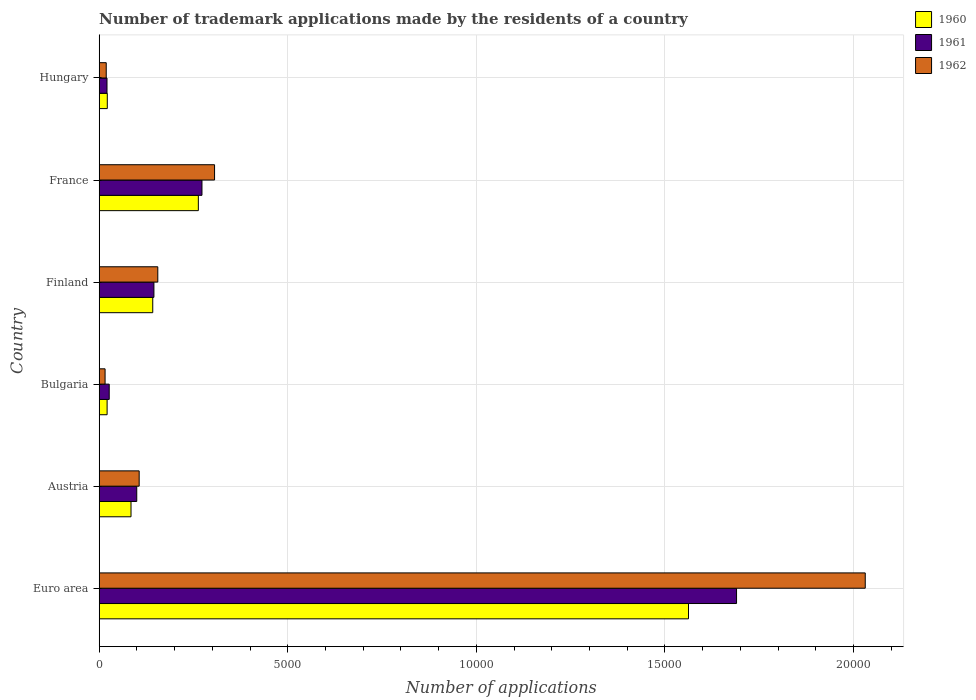How many groups of bars are there?
Your answer should be compact. 6. Are the number of bars on each tick of the Y-axis equal?
Your answer should be very brief. Yes. How many bars are there on the 4th tick from the top?
Your answer should be very brief. 3. How many bars are there on the 3rd tick from the bottom?
Give a very brief answer. 3. In how many cases, is the number of bars for a given country not equal to the number of legend labels?
Offer a very short reply. 0. What is the number of trademark applications made by the residents in 1962 in Austria?
Provide a short and direct response. 1061. Across all countries, what is the maximum number of trademark applications made by the residents in 1960?
Offer a very short reply. 1.56e+04. Across all countries, what is the minimum number of trademark applications made by the residents in 1962?
Provide a short and direct response. 157. In which country was the number of trademark applications made by the residents in 1960 maximum?
Make the answer very short. Euro area. In which country was the number of trademark applications made by the residents in 1962 minimum?
Provide a succinct answer. Bulgaria. What is the total number of trademark applications made by the residents in 1960 in the graph?
Your answer should be compact. 2.09e+04. What is the difference between the number of trademark applications made by the residents in 1960 in Euro area and that in France?
Offer a very short reply. 1.30e+04. What is the difference between the number of trademark applications made by the residents in 1961 in Euro area and the number of trademark applications made by the residents in 1960 in Hungary?
Provide a short and direct response. 1.67e+04. What is the average number of trademark applications made by the residents in 1961 per country?
Give a very brief answer. 3758.17. What is the difference between the number of trademark applications made by the residents in 1962 and number of trademark applications made by the residents in 1961 in France?
Keep it short and to the point. 334. What is the ratio of the number of trademark applications made by the residents in 1960 in Euro area to that in Hungary?
Provide a short and direct response. 72.34. Is the number of trademark applications made by the residents in 1960 in Austria less than that in Bulgaria?
Keep it short and to the point. No. What is the difference between the highest and the second highest number of trademark applications made by the residents in 1962?
Offer a very short reply. 1.73e+04. What is the difference between the highest and the lowest number of trademark applications made by the residents in 1960?
Offer a terse response. 1.54e+04. What does the 1st bar from the bottom in Euro area represents?
Ensure brevity in your answer.  1960. Are all the bars in the graph horizontal?
Provide a short and direct response. Yes. Are the values on the major ticks of X-axis written in scientific E-notation?
Ensure brevity in your answer.  No. How many legend labels are there?
Provide a short and direct response. 3. What is the title of the graph?
Your answer should be compact. Number of trademark applications made by the residents of a country. What is the label or title of the X-axis?
Provide a succinct answer. Number of applications. What is the Number of applications in 1960 in Euro area?
Ensure brevity in your answer.  1.56e+04. What is the Number of applications of 1961 in Euro area?
Provide a short and direct response. 1.69e+04. What is the Number of applications in 1962 in Euro area?
Your response must be concise. 2.03e+04. What is the Number of applications of 1960 in Austria?
Your answer should be compact. 845. What is the Number of applications of 1961 in Austria?
Ensure brevity in your answer.  997. What is the Number of applications of 1962 in Austria?
Offer a terse response. 1061. What is the Number of applications in 1960 in Bulgaria?
Make the answer very short. 211. What is the Number of applications in 1961 in Bulgaria?
Make the answer very short. 267. What is the Number of applications in 1962 in Bulgaria?
Your answer should be very brief. 157. What is the Number of applications of 1960 in Finland?
Your answer should be very brief. 1421. What is the Number of applications in 1961 in Finland?
Provide a succinct answer. 1452. What is the Number of applications in 1962 in Finland?
Make the answer very short. 1555. What is the Number of applications of 1960 in France?
Your answer should be very brief. 2630. What is the Number of applications of 1961 in France?
Make the answer very short. 2726. What is the Number of applications in 1962 in France?
Your answer should be very brief. 3060. What is the Number of applications of 1960 in Hungary?
Your answer should be compact. 216. What is the Number of applications in 1961 in Hungary?
Provide a succinct answer. 208. What is the Number of applications of 1962 in Hungary?
Make the answer very short. 188. Across all countries, what is the maximum Number of applications of 1960?
Provide a succinct answer. 1.56e+04. Across all countries, what is the maximum Number of applications of 1961?
Provide a succinct answer. 1.69e+04. Across all countries, what is the maximum Number of applications of 1962?
Ensure brevity in your answer.  2.03e+04. Across all countries, what is the minimum Number of applications of 1960?
Keep it short and to the point. 211. Across all countries, what is the minimum Number of applications in 1961?
Ensure brevity in your answer.  208. Across all countries, what is the minimum Number of applications in 1962?
Keep it short and to the point. 157. What is the total Number of applications of 1960 in the graph?
Keep it short and to the point. 2.09e+04. What is the total Number of applications in 1961 in the graph?
Your answer should be compact. 2.25e+04. What is the total Number of applications in 1962 in the graph?
Your answer should be very brief. 2.63e+04. What is the difference between the Number of applications in 1960 in Euro area and that in Austria?
Ensure brevity in your answer.  1.48e+04. What is the difference between the Number of applications in 1961 in Euro area and that in Austria?
Make the answer very short. 1.59e+04. What is the difference between the Number of applications of 1962 in Euro area and that in Austria?
Provide a succinct answer. 1.92e+04. What is the difference between the Number of applications of 1960 in Euro area and that in Bulgaria?
Make the answer very short. 1.54e+04. What is the difference between the Number of applications of 1961 in Euro area and that in Bulgaria?
Offer a terse response. 1.66e+04. What is the difference between the Number of applications of 1962 in Euro area and that in Bulgaria?
Offer a terse response. 2.02e+04. What is the difference between the Number of applications of 1960 in Euro area and that in Finland?
Your answer should be compact. 1.42e+04. What is the difference between the Number of applications in 1961 in Euro area and that in Finland?
Your answer should be very brief. 1.54e+04. What is the difference between the Number of applications in 1962 in Euro area and that in Finland?
Offer a very short reply. 1.88e+04. What is the difference between the Number of applications of 1960 in Euro area and that in France?
Your answer should be very brief. 1.30e+04. What is the difference between the Number of applications in 1961 in Euro area and that in France?
Offer a very short reply. 1.42e+04. What is the difference between the Number of applications of 1962 in Euro area and that in France?
Ensure brevity in your answer.  1.73e+04. What is the difference between the Number of applications in 1960 in Euro area and that in Hungary?
Offer a very short reply. 1.54e+04. What is the difference between the Number of applications of 1961 in Euro area and that in Hungary?
Offer a terse response. 1.67e+04. What is the difference between the Number of applications of 1962 in Euro area and that in Hungary?
Provide a short and direct response. 2.01e+04. What is the difference between the Number of applications of 1960 in Austria and that in Bulgaria?
Offer a terse response. 634. What is the difference between the Number of applications in 1961 in Austria and that in Bulgaria?
Your answer should be very brief. 730. What is the difference between the Number of applications of 1962 in Austria and that in Bulgaria?
Provide a short and direct response. 904. What is the difference between the Number of applications in 1960 in Austria and that in Finland?
Offer a terse response. -576. What is the difference between the Number of applications of 1961 in Austria and that in Finland?
Offer a very short reply. -455. What is the difference between the Number of applications of 1962 in Austria and that in Finland?
Provide a succinct answer. -494. What is the difference between the Number of applications of 1960 in Austria and that in France?
Provide a short and direct response. -1785. What is the difference between the Number of applications of 1961 in Austria and that in France?
Keep it short and to the point. -1729. What is the difference between the Number of applications of 1962 in Austria and that in France?
Provide a short and direct response. -1999. What is the difference between the Number of applications of 1960 in Austria and that in Hungary?
Give a very brief answer. 629. What is the difference between the Number of applications of 1961 in Austria and that in Hungary?
Ensure brevity in your answer.  789. What is the difference between the Number of applications of 1962 in Austria and that in Hungary?
Make the answer very short. 873. What is the difference between the Number of applications of 1960 in Bulgaria and that in Finland?
Give a very brief answer. -1210. What is the difference between the Number of applications in 1961 in Bulgaria and that in Finland?
Your answer should be very brief. -1185. What is the difference between the Number of applications of 1962 in Bulgaria and that in Finland?
Give a very brief answer. -1398. What is the difference between the Number of applications in 1960 in Bulgaria and that in France?
Your response must be concise. -2419. What is the difference between the Number of applications in 1961 in Bulgaria and that in France?
Keep it short and to the point. -2459. What is the difference between the Number of applications in 1962 in Bulgaria and that in France?
Offer a terse response. -2903. What is the difference between the Number of applications in 1961 in Bulgaria and that in Hungary?
Provide a succinct answer. 59. What is the difference between the Number of applications of 1962 in Bulgaria and that in Hungary?
Provide a short and direct response. -31. What is the difference between the Number of applications of 1960 in Finland and that in France?
Keep it short and to the point. -1209. What is the difference between the Number of applications of 1961 in Finland and that in France?
Offer a terse response. -1274. What is the difference between the Number of applications in 1962 in Finland and that in France?
Offer a terse response. -1505. What is the difference between the Number of applications of 1960 in Finland and that in Hungary?
Ensure brevity in your answer.  1205. What is the difference between the Number of applications in 1961 in Finland and that in Hungary?
Offer a very short reply. 1244. What is the difference between the Number of applications of 1962 in Finland and that in Hungary?
Provide a short and direct response. 1367. What is the difference between the Number of applications in 1960 in France and that in Hungary?
Give a very brief answer. 2414. What is the difference between the Number of applications of 1961 in France and that in Hungary?
Make the answer very short. 2518. What is the difference between the Number of applications in 1962 in France and that in Hungary?
Offer a terse response. 2872. What is the difference between the Number of applications of 1960 in Euro area and the Number of applications of 1961 in Austria?
Your answer should be very brief. 1.46e+04. What is the difference between the Number of applications in 1960 in Euro area and the Number of applications in 1962 in Austria?
Make the answer very short. 1.46e+04. What is the difference between the Number of applications of 1961 in Euro area and the Number of applications of 1962 in Austria?
Your answer should be very brief. 1.58e+04. What is the difference between the Number of applications in 1960 in Euro area and the Number of applications in 1961 in Bulgaria?
Make the answer very short. 1.54e+04. What is the difference between the Number of applications in 1960 in Euro area and the Number of applications in 1962 in Bulgaria?
Provide a short and direct response. 1.55e+04. What is the difference between the Number of applications of 1961 in Euro area and the Number of applications of 1962 in Bulgaria?
Your answer should be compact. 1.67e+04. What is the difference between the Number of applications of 1960 in Euro area and the Number of applications of 1961 in Finland?
Offer a terse response. 1.42e+04. What is the difference between the Number of applications of 1960 in Euro area and the Number of applications of 1962 in Finland?
Make the answer very short. 1.41e+04. What is the difference between the Number of applications in 1961 in Euro area and the Number of applications in 1962 in Finland?
Give a very brief answer. 1.53e+04. What is the difference between the Number of applications of 1960 in Euro area and the Number of applications of 1961 in France?
Ensure brevity in your answer.  1.29e+04. What is the difference between the Number of applications in 1960 in Euro area and the Number of applications in 1962 in France?
Give a very brief answer. 1.26e+04. What is the difference between the Number of applications in 1961 in Euro area and the Number of applications in 1962 in France?
Offer a very short reply. 1.38e+04. What is the difference between the Number of applications in 1960 in Euro area and the Number of applications in 1961 in Hungary?
Offer a terse response. 1.54e+04. What is the difference between the Number of applications in 1960 in Euro area and the Number of applications in 1962 in Hungary?
Make the answer very short. 1.54e+04. What is the difference between the Number of applications in 1961 in Euro area and the Number of applications in 1962 in Hungary?
Your response must be concise. 1.67e+04. What is the difference between the Number of applications in 1960 in Austria and the Number of applications in 1961 in Bulgaria?
Give a very brief answer. 578. What is the difference between the Number of applications in 1960 in Austria and the Number of applications in 1962 in Bulgaria?
Ensure brevity in your answer.  688. What is the difference between the Number of applications in 1961 in Austria and the Number of applications in 1962 in Bulgaria?
Offer a terse response. 840. What is the difference between the Number of applications in 1960 in Austria and the Number of applications in 1961 in Finland?
Provide a succinct answer. -607. What is the difference between the Number of applications in 1960 in Austria and the Number of applications in 1962 in Finland?
Keep it short and to the point. -710. What is the difference between the Number of applications in 1961 in Austria and the Number of applications in 1962 in Finland?
Your answer should be compact. -558. What is the difference between the Number of applications in 1960 in Austria and the Number of applications in 1961 in France?
Give a very brief answer. -1881. What is the difference between the Number of applications in 1960 in Austria and the Number of applications in 1962 in France?
Offer a terse response. -2215. What is the difference between the Number of applications in 1961 in Austria and the Number of applications in 1962 in France?
Offer a very short reply. -2063. What is the difference between the Number of applications in 1960 in Austria and the Number of applications in 1961 in Hungary?
Make the answer very short. 637. What is the difference between the Number of applications of 1960 in Austria and the Number of applications of 1962 in Hungary?
Provide a short and direct response. 657. What is the difference between the Number of applications in 1961 in Austria and the Number of applications in 1962 in Hungary?
Your answer should be very brief. 809. What is the difference between the Number of applications of 1960 in Bulgaria and the Number of applications of 1961 in Finland?
Provide a succinct answer. -1241. What is the difference between the Number of applications in 1960 in Bulgaria and the Number of applications in 1962 in Finland?
Offer a terse response. -1344. What is the difference between the Number of applications in 1961 in Bulgaria and the Number of applications in 1962 in Finland?
Your response must be concise. -1288. What is the difference between the Number of applications of 1960 in Bulgaria and the Number of applications of 1961 in France?
Provide a short and direct response. -2515. What is the difference between the Number of applications of 1960 in Bulgaria and the Number of applications of 1962 in France?
Your response must be concise. -2849. What is the difference between the Number of applications of 1961 in Bulgaria and the Number of applications of 1962 in France?
Your answer should be very brief. -2793. What is the difference between the Number of applications in 1960 in Bulgaria and the Number of applications in 1962 in Hungary?
Offer a very short reply. 23. What is the difference between the Number of applications in 1961 in Bulgaria and the Number of applications in 1962 in Hungary?
Keep it short and to the point. 79. What is the difference between the Number of applications in 1960 in Finland and the Number of applications in 1961 in France?
Give a very brief answer. -1305. What is the difference between the Number of applications in 1960 in Finland and the Number of applications in 1962 in France?
Your answer should be compact. -1639. What is the difference between the Number of applications of 1961 in Finland and the Number of applications of 1962 in France?
Provide a short and direct response. -1608. What is the difference between the Number of applications of 1960 in Finland and the Number of applications of 1961 in Hungary?
Your response must be concise. 1213. What is the difference between the Number of applications of 1960 in Finland and the Number of applications of 1962 in Hungary?
Your response must be concise. 1233. What is the difference between the Number of applications in 1961 in Finland and the Number of applications in 1962 in Hungary?
Your answer should be very brief. 1264. What is the difference between the Number of applications in 1960 in France and the Number of applications in 1961 in Hungary?
Offer a terse response. 2422. What is the difference between the Number of applications of 1960 in France and the Number of applications of 1962 in Hungary?
Offer a terse response. 2442. What is the difference between the Number of applications in 1961 in France and the Number of applications in 1962 in Hungary?
Make the answer very short. 2538. What is the average Number of applications of 1960 per country?
Give a very brief answer. 3491.33. What is the average Number of applications in 1961 per country?
Offer a very short reply. 3758.17. What is the average Number of applications in 1962 per country?
Offer a very short reply. 4388.67. What is the difference between the Number of applications in 1960 and Number of applications in 1961 in Euro area?
Ensure brevity in your answer.  -1274. What is the difference between the Number of applications in 1960 and Number of applications in 1962 in Euro area?
Provide a short and direct response. -4686. What is the difference between the Number of applications of 1961 and Number of applications of 1962 in Euro area?
Your response must be concise. -3412. What is the difference between the Number of applications in 1960 and Number of applications in 1961 in Austria?
Provide a succinct answer. -152. What is the difference between the Number of applications of 1960 and Number of applications of 1962 in Austria?
Make the answer very short. -216. What is the difference between the Number of applications of 1961 and Number of applications of 1962 in Austria?
Provide a short and direct response. -64. What is the difference between the Number of applications in 1960 and Number of applications in 1961 in Bulgaria?
Give a very brief answer. -56. What is the difference between the Number of applications in 1960 and Number of applications in 1962 in Bulgaria?
Give a very brief answer. 54. What is the difference between the Number of applications of 1961 and Number of applications of 1962 in Bulgaria?
Your answer should be compact. 110. What is the difference between the Number of applications in 1960 and Number of applications in 1961 in Finland?
Give a very brief answer. -31. What is the difference between the Number of applications in 1960 and Number of applications in 1962 in Finland?
Ensure brevity in your answer.  -134. What is the difference between the Number of applications in 1961 and Number of applications in 1962 in Finland?
Give a very brief answer. -103. What is the difference between the Number of applications of 1960 and Number of applications of 1961 in France?
Your answer should be compact. -96. What is the difference between the Number of applications in 1960 and Number of applications in 1962 in France?
Offer a very short reply. -430. What is the difference between the Number of applications in 1961 and Number of applications in 1962 in France?
Provide a succinct answer. -334. What is the ratio of the Number of applications of 1960 in Euro area to that in Austria?
Offer a terse response. 18.49. What is the ratio of the Number of applications in 1961 in Euro area to that in Austria?
Your answer should be very brief. 16.95. What is the ratio of the Number of applications in 1962 in Euro area to that in Austria?
Keep it short and to the point. 19.14. What is the ratio of the Number of applications in 1960 in Euro area to that in Bulgaria?
Give a very brief answer. 74.05. What is the ratio of the Number of applications of 1961 in Euro area to that in Bulgaria?
Your answer should be compact. 63.29. What is the ratio of the Number of applications in 1962 in Euro area to that in Bulgaria?
Provide a short and direct response. 129.37. What is the ratio of the Number of applications of 1960 in Euro area to that in Finland?
Your answer should be very brief. 11. What is the ratio of the Number of applications in 1961 in Euro area to that in Finland?
Offer a terse response. 11.64. What is the ratio of the Number of applications of 1962 in Euro area to that in Finland?
Give a very brief answer. 13.06. What is the ratio of the Number of applications of 1960 in Euro area to that in France?
Ensure brevity in your answer.  5.94. What is the ratio of the Number of applications in 1961 in Euro area to that in France?
Provide a short and direct response. 6.2. What is the ratio of the Number of applications of 1962 in Euro area to that in France?
Offer a terse response. 6.64. What is the ratio of the Number of applications of 1960 in Euro area to that in Hungary?
Make the answer very short. 72.34. What is the ratio of the Number of applications of 1961 in Euro area to that in Hungary?
Provide a succinct answer. 81.25. What is the ratio of the Number of applications in 1962 in Euro area to that in Hungary?
Provide a succinct answer. 108.04. What is the ratio of the Number of applications in 1960 in Austria to that in Bulgaria?
Make the answer very short. 4. What is the ratio of the Number of applications in 1961 in Austria to that in Bulgaria?
Your response must be concise. 3.73. What is the ratio of the Number of applications of 1962 in Austria to that in Bulgaria?
Your answer should be very brief. 6.76. What is the ratio of the Number of applications in 1960 in Austria to that in Finland?
Make the answer very short. 0.59. What is the ratio of the Number of applications in 1961 in Austria to that in Finland?
Give a very brief answer. 0.69. What is the ratio of the Number of applications of 1962 in Austria to that in Finland?
Give a very brief answer. 0.68. What is the ratio of the Number of applications in 1960 in Austria to that in France?
Your answer should be very brief. 0.32. What is the ratio of the Number of applications in 1961 in Austria to that in France?
Offer a terse response. 0.37. What is the ratio of the Number of applications of 1962 in Austria to that in France?
Give a very brief answer. 0.35. What is the ratio of the Number of applications of 1960 in Austria to that in Hungary?
Offer a very short reply. 3.91. What is the ratio of the Number of applications in 1961 in Austria to that in Hungary?
Offer a terse response. 4.79. What is the ratio of the Number of applications of 1962 in Austria to that in Hungary?
Your answer should be very brief. 5.64. What is the ratio of the Number of applications of 1960 in Bulgaria to that in Finland?
Offer a terse response. 0.15. What is the ratio of the Number of applications in 1961 in Bulgaria to that in Finland?
Provide a short and direct response. 0.18. What is the ratio of the Number of applications of 1962 in Bulgaria to that in Finland?
Provide a short and direct response. 0.1. What is the ratio of the Number of applications in 1960 in Bulgaria to that in France?
Ensure brevity in your answer.  0.08. What is the ratio of the Number of applications of 1961 in Bulgaria to that in France?
Keep it short and to the point. 0.1. What is the ratio of the Number of applications of 1962 in Bulgaria to that in France?
Provide a short and direct response. 0.05. What is the ratio of the Number of applications of 1960 in Bulgaria to that in Hungary?
Your answer should be very brief. 0.98. What is the ratio of the Number of applications in 1961 in Bulgaria to that in Hungary?
Offer a terse response. 1.28. What is the ratio of the Number of applications of 1962 in Bulgaria to that in Hungary?
Offer a very short reply. 0.84. What is the ratio of the Number of applications in 1960 in Finland to that in France?
Provide a short and direct response. 0.54. What is the ratio of the Number of applications in 1961 in Finland to that in France?
Ensure brevity in your answer.  0.53. What is the ratio of the Number of applications of 1962 in Finland to that in France?
Your answer should be very brief. 0.51. What is the ratio of the Number of applications of 1960 in Finland to that in Hungary?
Provide a succinct answer. 6.58. What is the ratio of the Number of applications of 1961 in Finland to that in Hungary?
Ensure brevity in your answer.  6.98. What is the ratio of the Number of applications of 1962 in Finland to that in Hungary?
Your response must be concise. 8.27. What is the ratio of the Number of applications of 1960 in France to that in Hungary?
Your response must be concise. 12.18. What is the ratio of the Number of applications in 1961 in France to that in Hungary?
Offer a very short reply. 13.11. What is the ratio of the Number of applications of 1962 in France to that in Hungary?
Keep it short and to the point. 16.28. What is the difference between the highest and the second highest Number of applications in 1960?
Provide a succinct answer. 1.30e+04. What is the difference between the highest and the second highest Number of applications of 1961?
Your response must be concise. 1.42e+04. What is the difference between the highest and the second highest Number of applications in 1962?
Give a very brief answer. 1.73e+04. What is the difference between the highest and the lowest Number of applications in 1960?
Offer a terse response. 1.54e+04. What is the difference between the highest and the lowest Number of applications of 1961?
Offer a terse response. 1.67e+04. What is the difference between the highest and the lowest Number of applications of 1962?
Offer a terse response. 2.02e+04. 